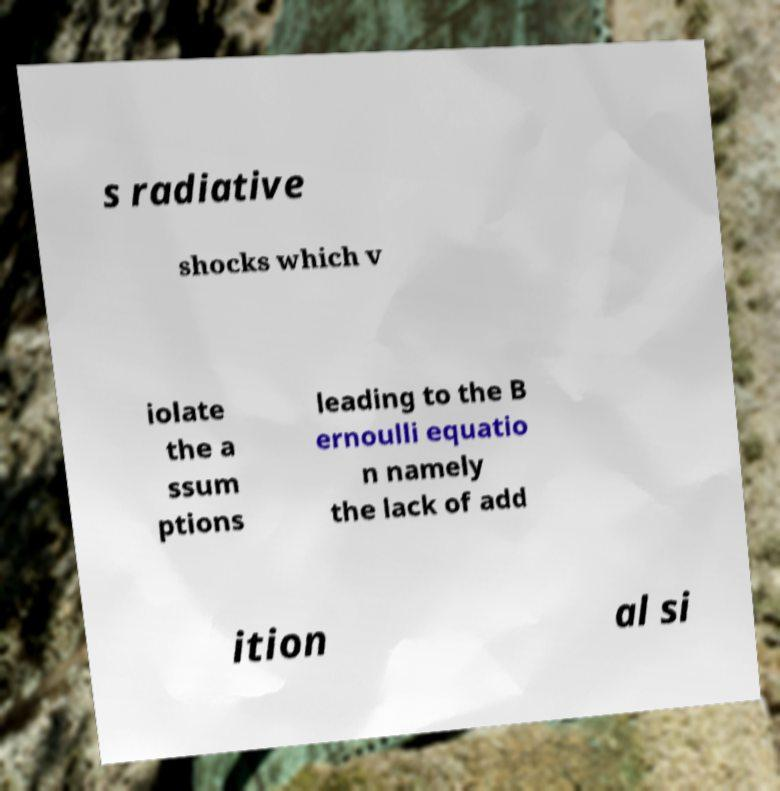Could you assist in decoding the text presented in this image and type it out clearly? s radiative shocks which v iolate the a ssum ptions leading to the B ernoulli equatio n namely the lack of add ition al si 